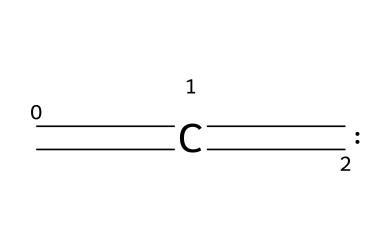What is the molecular formula of ethylene carbene? To determine the molecular formula, count the number of carbon atoms and hydrogen atoms in the structure represented by the SMILES. There are three carbon atoms and four hydrogen atoms indicated in the structure, resulting in the molecular formula C3H4.
Answer: C3H4 How many double bonds are present in this carbene? The SMILES representation shows two equal signs, which indicate double bonds. Therefore, there are two double bonds in the ethylene carbene structure.
Answer: 2 What type of hybridization does the central carbon exhibit in ethylene carbene? In the structure of ethylene carbene, the central carbon is engaged in the formation of a double bond and has two other single bonds. This indicates an sp2 hybridization for the central carbon atom, given that it is bonded to three groups (two from double bonds and one from a single bond).
Answer: sp2 What is the general structure of a carbene? Carbenes are molecules featuring a carbon atom with only six electrons in its valence shell and typically have two unshared electrons. The structure seen here fits this definition with the central carbon having a valency of two, which leaves it electron-deficient.
Answer: electron-deficient carbon Is ethylene carbene stable or reactive? Carbenes are known to be highly reactive due to their electron deficiency, and ethylene carbene, in particular, is quite reactive. This characteristic arises from their unstable nature when the carbon atom does not have a complete octet.
Answer: reactive What type of isomerism can ethylene carbene exhibit? Ethylene carbene can show isomerism due to the presence of different configurations around the double bonds and the central carbene carbon. Specifically, it can exhibit both cis and trans forms relative to its structure.
Answer: cis/trans isomerism 